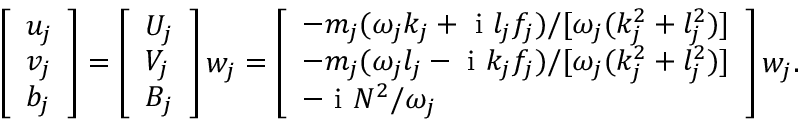Convert formula to latex. <formula><loc_0><loc_0><loc_500><loc_500>\begin{array} { r } { \left [ \begin{array} { l } { u _ { j } } \\ { v _ { j } } \\ { b _ { j } } \end{array} \right ] = \left [ \begin{array} { l } { U _ { j } } \\ { V _ { j } } \\ { B _ { j } } \end{array} \right ] w _ { j } = \left [ \begin{array} { l } { - { m _ { j } ( \omega _ { j } k _ { j } + i l _ { j } f _ { j } ) } { / [ \omega _ { j } ( k _ { j } ^ { 2 } + l _ { j } ^ { 2 } ) ] } } \\ { - { m _ { j } ( \omega _ { j } l _ { j } - i k _ { j } f _ { j } ) } { / [ \omega _ { j } ( k _ { j } ^ { 2 } + l _ { j } ^ { 2 } ) ] } } \\ { - i { N ^ { 2 } } { / \omega _ { j } } } \end{array} \right ] w _ { j } . } \end{array}</formula> 